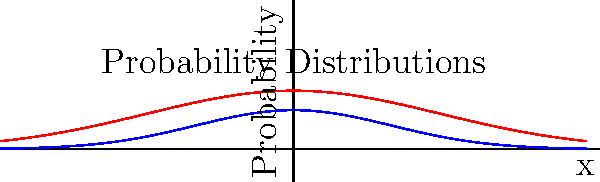In a poker hand simulation, you've plotted the probability distribution of a certain statistic. After applying a scaling transformation, you observe the change shown in the graph. The blue curve represents the original distribution, and the red curve shows the scaled distribution. How does this scaling affect the standard deviation of the distribution? To determine how the scaling affects the standard deviation, let's analyze the transformation step-by-step:

1. The original distribution (blue curve) appears to be a standard normal distribution with mean 0 and standard deviation 1.

2. The scaled distribution (red curve) is wider and shorter than the original, which suggests a scaling operation has been applied.

3. The scaling transformation can be described as:
   $f(x) \rightarrow \alpha f(x/\alpha)$, where $\alpha > 1$

4. From the graph, we can estimate that $\alpha \approx 1.5$, as the scaled curve is about 1.5 times wider than the original.

5. For a normal distribution, scaling by a factor $\alpha$ affects the standard deviation as follows:
   If $X \sim N(\mu, \sigma^2)$, then $\alpha X \sim N(\alpha\mu, \alpha^2\sigma^2)$

6. In this case, $\mu = 0$, so the mean doesn't change. The standard deviation, however, is multiplied by $\alpha$.

7. Therefore, the new standard deviation is approximately 1.5 times the original standard deviation.
Answer: The standard deviation increases by a factor of approximately 1.5. 